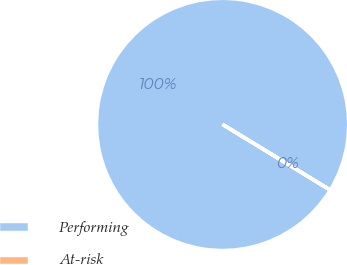Convert chart. <chart><loc_0><loc_0><loc_500><loc_500><pie_chart><fcel>Performing<fcel>At-risk<nl><fcel>99.99%<fcel>0.01%<nl></chart> 